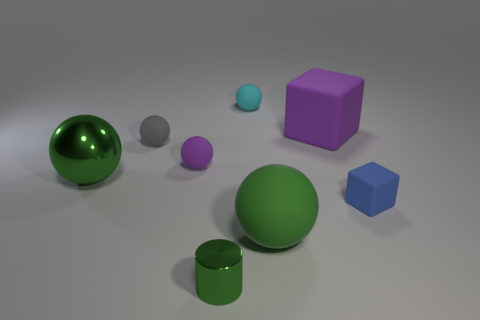Subtract all big green balls. How many balls are left? 3 Add 1 large green shiny spheres. How many objects exist? 9 Subtract all green balls. How many balls are left? 3 Subtract all balls. How many objects are left? 3 Subtract 2 spheres. How many spheres are left? 3 Subtract all green cylinders. How many gray spheres are left? 1 Subtract all large brown shiny objects. Subtract all cyan spheres. How many objects are left? 7 Add 6 tiny purple things. How many tiny purple things are left? 7 Add 7 tiny cyan spheres. How many tiny cyan spheres exist? 8 Subtract 1 green balls. How many objects are left? 7 